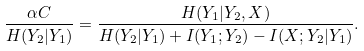<formula> <loc_0><loc_0><loc_500><loc_500>\frac { \alpha C } { H ( Y _ { 2 } | Y _ { 1 } ) } = \frac { H ( Y _ { 1 } | Y _ { 2 } , X ) } { H ( Y _ { 2 } | Y _ { 1 } ) + I ( Y _ { 1 } ; Y _ { 2 } ) - I ( X ; Y _ { 2 } | Y _ { 1 } ) } .</formula> 